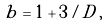<formula> <loc_0><loc_0><loc_500><loc_500>b = 1 + 3 / D \, , \,</formula> 